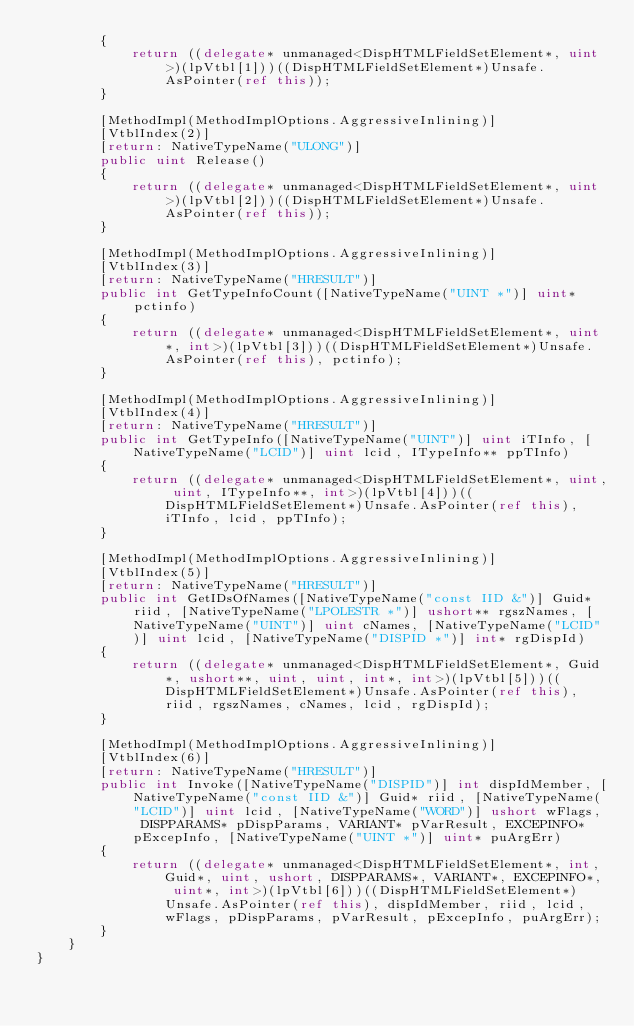Convert code to text. <code><loc_0><loc_0><loc_500><loc_500><_C#_>        {
            return ((delegate* unmanaged<DispHTMLFieldSetElement*, uint>)(lpVtbl[1]))((DispHTMLFieldSetElement*)Unsafe.AsPointer(ref this));
        }

        [MethodImpl(MethodImplOptions.AggressiveInlining)]
        [VtblIndex(2)]
        [return: NativeTypeName("ULONG")]
        public uint Release()
        {
            return ((delegate* unmanaged<DispHTMLFieldSetElement*, uint>)(lpVtbl[2]))((DispHTMLFieldSetElement*)Unsafe.AsPointer(ref this));
        }

        [MethodImpl(MethodImplOptions.AggressiveInlining)]
        [VtblIndex(3)]
        [return: NativeTypeName("HRESULT")]
        public int GetTypeInfoCount([NativeTypeName("UINT *")] uint* pctinfo)
        {
            return ((delegate* unmanaged<DispHTMLFieldSetElement*, uint*, int>)(lpVtbl[3]))((DispHTMLFieldSetElement*)Unsafe.AsPointer(ref this), pctinfo);
        }

        [MethodImpl(MethodImplOptions.AggressiveInlining)]
        [VtblIndex(4)]
        [return: NativeTypeName("HRESULT")]
        public int GetTypeInfo([NativeTypeName("UINT")] uint iTInfo, [NativeTypeName("LCID")] uint lcid, ITypeInfo** ppTInfo)
        {
            return ((delegate* unmanaged<DispHTMLFieldSetElement*, uint, uint, ITypeInfo**, int>)(lpVtbl[4]))((DispHTMLFieldSetElement*)Unsafe.AsPointer(ref this), iTInfo, lcid, ppTInfo);
        }

        [MethodImpl(MethodImplOptions.AggressiveInlining)]
        [VtblIndex(5)]
        [return: NativeTypeName("HRESULT")]
        public int GetIDsOfNames([NativeTypeName("const IID &")] Guid* riid, [NativeTypeName("LPOLESTR *")] ushort** rgszNames, [NativeTypeName("UINT")] uint cNames, [NativeTypeName("LCID")] uint lcid, [NativeTypeName("DISPID *")] int* rgDispId)
        {
            return ((delegate* unmanaged<DispHTMLFieldSetElement*, Guid*, ushort**, uint, uint, int*, int>)(lpVtbl[5]))((DispHTMLFieldSetElement*)Unsafe.AsPointer(ref this), riid, rgszNames, cNames, lcid, rgDispId);
        }

        [MethodImpl(MethodImplOptions.AggressiveInlining)]
        [VtblIndex(6)]
        [return: NativeTypeName("HRESULT")]
        public int Invoke([NativeTypeName("DISPID")] int dispIdMember, [NativeTypeName("const IID &")] Guid* riid, [NativeTypeName("LCID")] uint lcid, [NativeTypeName("WORD")] ushort wFlags, DISPPARAMS* pDispParams, VARIANT* pVarResult, EXCEPINFO* pExcepInfo, [NativeTypeName("UINT *")] uint* puArgErr)
        {
            return ((delegate* unmanaged<DispHTMLFieldSetElement*, int, Guid*, uint, ushort, DISPPARAMS*, VARIANT*, EXCEPINFO*, uint*, int>)(lpVtbl[6]))((DispHTMLFieldSetElement*)Unsafe.AsPointer(ref this), dispIdMember, riid, lcid, wFlags, pDispParams, pVarResult, pExcepInfo, puArgErr);
        }
    }
}
</code> 